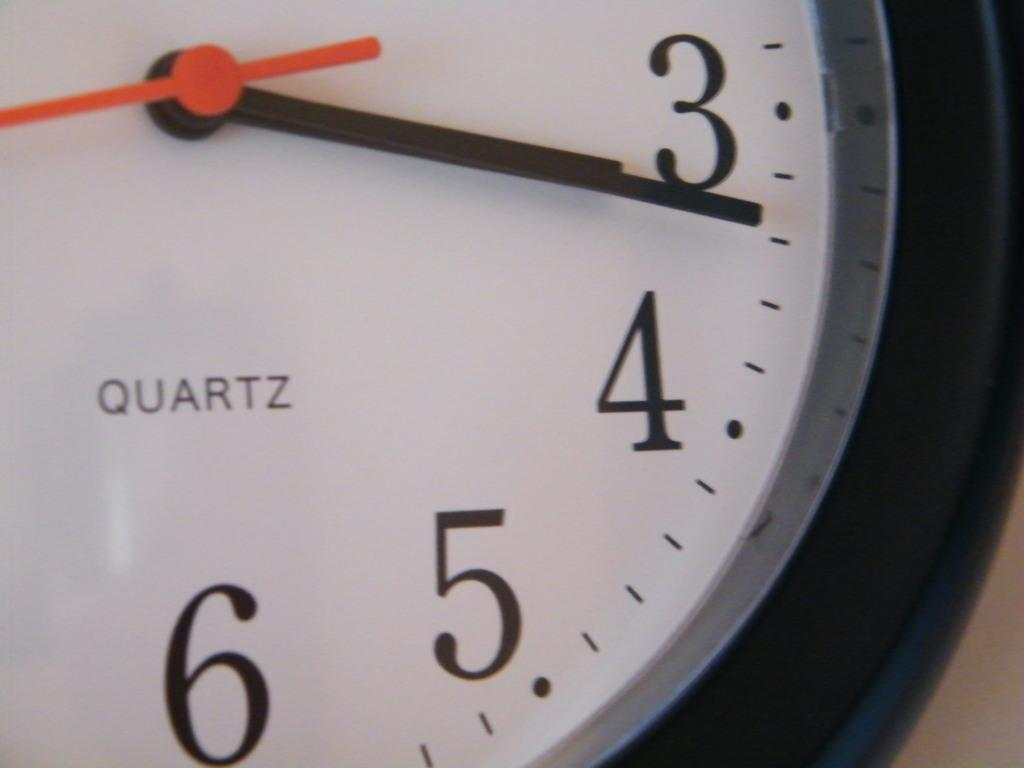<image>
Give a short and clear explanation of the subsequent image. A Quartz watch is on display with a white background 